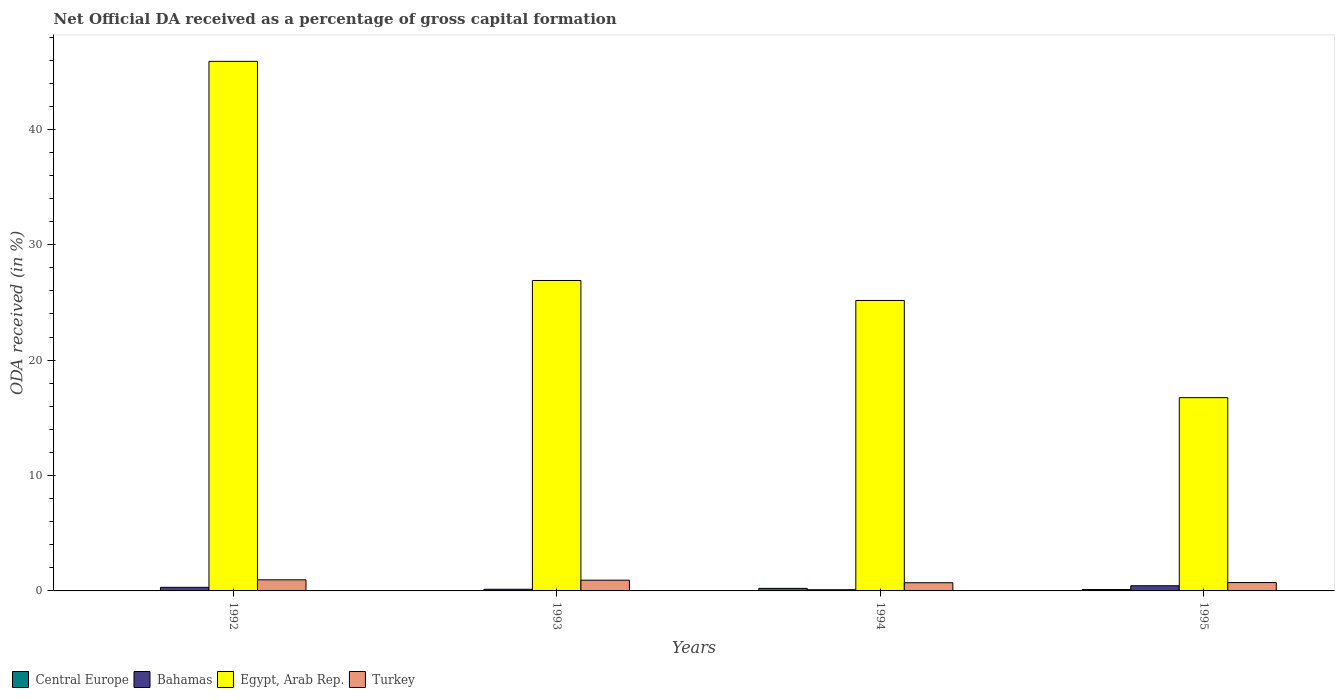How many different coloured bars are there?
Make the answer very short. 4. How many groups of bars are there?
Provide a short and direct response. 4. Are the number of bars per tick equal to the number of legend labels?
Your answer should be very brief. Yes. What is the label of the 4th group of bars from the left?
Make the answer very short. 1995. In how many cases, is the number of bars for a given year not equal to the number of legend labels?
Offer a very short reply. 0. What is the net ODA received in Egypt, Arab Rep. in 1994?
Your answer should be very brief. 25.17. Across all years, what is the maximum net ODA received in Central Europe?
Keep it short and to the point. 0.22. Across all years, what is the minimum net ODA received in Turkey?
Give a very brief answer. 0.71. In which year was the net ODA received in Turkey maximum?
Offer a very short reply. 1992. In which year was the net ODA received in Bahamas minimum?
Your response must be concise. 1994. What is the total net ODA received in Turkey in the graph?
Your answer should be very brief. 3.33. What is the difference between the net ODA received in Bahamas in 1994 and that in 1995?
Provide a short and direct response. -0.35. What is the difference between the net ODA received in Egypt, Arab Rep. in 1994 and the net ODA received in Bahamas in 1995?
Ensure brevity in your answer.  24.72. What is the average net ODA received in Egypt, Arab Rep. per year?
Your response must be concise. 28.68. In the year 1992, what is the difference between the net ODA received in Egypt, Arab Rep. and net ODA received in Central Europe?
Provide a short and direct response. 45.89. What is the ratio of the net ODA received in Turkey in 1994 to that in 1995?
Provide a short and direct response. 0.98. What is the difference between the highest and the second highest net ODA received in Turkey?
Provide a succinct answer. 0.03. What is the difference between the highest and the lowest net ODA received in Central Europe?
Keep it short and to the point. 0.22. Is it the case that in every year, the sum of the net ODA received in Central Europe and net ODA received in Turkey is greater than the sum of net ODA received in Bahamas and net ODA received in Egypt, Arab Rep.?
Provide a short and direct response. Yes. What does the 1st bar from the right in 1993 represents?
Ensure brevity in your answer.  Turkey. Is it the case that in every year, the sum of the net ODA received in Turkey and net ODA received in Egypt, Arab Rep. is greater than the net ODA received in Bahamas?
Your response must be concise. Yes. Are all the bars in the graph horizontal?
Make the answer very short. No. How many years are there in the graph?
Give a very brief answer. 4. What is the difference between two consecutive major ticks on the Y-axis?
Ensure brevity in your answer.  10. Are the values on the major ticks of Y-axis written in scientific E-notation?
Provide a short and direct response. No. Does the graph contain any zero values?
Your response must be concise. No. Does the graph contain grids?
Offer a very short reply. No. Where does the legend appear in the graph?
Offer a very short reply. Bottom left. What is the title of the graph?
Your answer should be very brief. Net Official DA received as a percentage of gross capital formation. Does "Korea (Republic)" appear as one of the legend labels in the graph?
Provide a short and direct response. No. What is the label or title of the X-axis?
Offer a terse response. Years. What is the label or title of the Y-axis?
Keep it short and to the point. ODA received (in %). What is the ODA received (in %) in Central Europe in 1992?
Make the answer very short. 2.00332790162036e-5. What is the ODA received (in %) in Bahamas in 1992?
Make the answer very short. 0.31. What is the ODA received (in %) of Egypt, Arab Rep. in 1992?
Your answer should be compact. 45.89. What is the ODA received (in %) in Turkey in 1992?
Your answer should be compact. 0.96. What is the ODA received (in %) of Central Europe in 1993?
Ensure brevity in your answer.  0.01. What is the ODA received (in %) of Bahamas in 1993?
Your answer should be very brief. 0.14. What is the ODA received (in %) in Egypt, Arab Rep. in 1993?
Give a very brief answer. 26.9. What is the ODA received (in %) in Turkey in 1993?
Offer a very short reply. 0.93. What is the ODA received (in %) of Central Europe in 1994?
Keep it short and to the point. 0.22. What is the ODA received (in %) of Bahamas in 1994?
Give a very brief answer. 0.1. What is the ODA received (in %) in Egypt, Arab Rep. in 1994?
Provide a succinct answer. 25.17. What is the ODA received (in %) in Turkey in 1994?
Offer a very short reply. 0.71. What is the ODA received (in %) in Central Europe in 1995?
Ensure brevity in your answer.  0.12. What is the ODA received (in %) in Bahamas in 1995?
Ensure brevity in your answer.  0.45. What is the ODA received (in %) of Egypt, Arab Rep. in 1995?
Give a very brief answer. 16.75. What is the ODA received (in %) of Turkey in 1995?
Provide a succinct answer. 0.72. Across all years, what is the maximum ODA received (in %) of Central Europe?
Offer a very short reply. 0.22. Across all years, what is the maximum ODA received (in %) of Bahamas?
Provide a short and direct response. 0.45. Across all years, what is the maximum ODA received (in %) of Egypt, Arab Rep.?
Your answer should be very brief. 45.89. Across all years, what is the maximum ODA received (in %) in Turkey?
Provide a succinct answer. 0.96. Across all years, what is the minimum ODA received (in %) in Central Europe?
Your answer should be compact. 2.00332790162036e-5. Across all years, what is the minimum ODA received (in %) in Bahamas?
Your answer should be very brief. 0.1. Across all years, what is the minimum ODA received (in %) in Egypt, Arab Rep.?
Keep it short and to the point. 16.75. Across all years, what is the minimum ODA received (in %) in Turkey?
Your answer should be compact. 0.71. What is the total ODA received (in %) of Central Europe in the graph?
Provide a short and direct response. 0.35. What is the total ODA received (in %) in Bahamas in the graph?
Ensure brevity in your answer.  1.01. What is the total ODA received (in %) of Egypt, Arab Rep. in the graph?
Your answer should be compact. 114.72. What is the total ODA received (in %) in Turkey in the graph?
Provide a short and direct response. 3.33. What is the difference between the ODA received (in %) of Central Europe in 1992 and that in 1993?
Provide a short and direct response. -0.01. What is the difference between the ODA received (in %) of Bahamas in 1992 and that in 1993?
Your answer should be compact. 0.17. What is the difference between the ODA received (in %) of Egypt, Arab Rep. in 1992 and that in 1993?
Ensure brevity in your answer.  18.99. What is the difference between the ODA received (in %) in Turkey in 1992 and that in 1993?
Give a very brief answer. 0.03. What is the difference between the ODA received (in %) in Central Europe in 1992 and that in 1994?
Give a very brief answer. -0.22. What is the difference between the ODA received (in %) in Bahamas in 1992 and that in 1994?
Provide a short and direct response. 0.21. What is the difference between the ODA received (in %) in Egypt, Arab Rep. in 1992 and that in 1994?
Your answer should be very brief. 20.72. What is the difference between the ODA received (in %) in Turkey in 1992 and that in 1994?
Offer a terse response. 0.25. What is the difference between the ODA received (in %) in Central Europe in 1992 and that in 1995?
Offer a terse response. -0.12. What is the difference between the ODA received (in %) of Bahamas in 1992 and that in 1995?
Offer a terse response. -0.14. What is the difference between the ODA received (in %) in Egypt, Arab Rep. in 1992 and that in 1995?
Your answer should be very brief. 29.15. What is the difference between the ODA received (in %) in Turkey in 1992 and that in 1995?
Give a very brief answer. 0.24. What is the difference between the ODA received (in %) of Central Europe in 1993 and that in 1994?
Offer a terse response. -0.21. What is the difference between the ODA received (in %) in Bahamas in 1993 and that in 1994?
Provide a short and direct response. 0.04. What is the difference between the ODA received (in %) in Egypt, Arab Rep. in 1993 and that in 1994?
Provide a succinct answer. 1.73. What is the difference between the ODA received (in %) in Turkey in 1993 and that in 1994?
Ensure brevity in your answer.  0.22. What is the difference between the ODA received (in %) in Central Europe in 1993 and that in 1995?
Offer a terse response. -0.11. What is the difference between the ODA received (in %) in Bahamas in 1993 and that in 1995?
Offer a very short reply. -0.31. What is the difference between the ODA received (in %) of Egypt, Arab Rep. in 1993 and that in 1995?
Provide a short and direct response. 10.16. What is the difference between the ODA received (in %) of Turkey in 1993 and that in 1995?
Offer a terse response. 0.21. What is the difference between the ODA received (in %) of Central Europe in 1994 and that in 1995?
Your response must be concise. 0.1. What is the difference between the ODA received (in %) in Bahamas in 1994 and that in 1995?
Provide a short and direct response. -0.35. What is the difference between the ODA received (in %) of Egypt, Arab Rep. in 1994 and that in 1995?
Provide a succinct answer. 8.42. What is the difference between the ODA received (in %) of Turkey in 1994 and that in 1995?
Your answer should be very brief. -0.02. What is the difference between the ODA received (in %) in Central Europe in 1992 and the ODA received (in %) in Bahamas in 1993?
Keep it short and to the point. -0.14. What is the difference between the ODA received (in %) of Central Europe in 1992 and the ODA received (in %) of Egypt, Arab Rep. in 1993?
Give a very brief answer. -26.9. What is the difference between the ODA received (in %) in Central Europe in 1992 and the ODA received (in %) in Turkey in 1993?
Provide a short and direct response. -0.93. What is the difference between the ODA received (in %) of Bahamas in 1992 and the ODA received (in %) of Egypt, Arab Rep. in 1993?
Your answer should be compact. -26.59. What is the difference between the ODA received (in %) in Bahamas in 1992 and the ODA received (in %) in Turkey in 1993?
Offer a very short reply. -0.62. What is the difference between the ODA received (in %) of Egypt, Arab Rep. in 1992 and the ODA received (in %) of Turkey in 1993?
Make the answer very short. 44.96. What is the difference between the ODA received (in %) in Central Europe in 1992 and the ODA received (in %) in Bahamas in 1994?
Keep it short and to the point. -0.1. What is the difference between the ODA received (in %) of Central Europe in 1992 and the ODA received (in %) of Egypt, Arab Rep. in 1994?
Provide a succinct answer. -25.17. What is the difference between the ODA received (in %) in Central Europe in 1992 and the ODA received (in %) in Turkey in 1994?
Your response must be concise. -0.71. What is the difference between the ODA received (in %) of Bahamas in 1992 and the ODA received (in %) of Egypt, Arab Rep. in 1994?
Offer a very short reply. -24.86. What is the difference between the ODA received (in %) of Bahamas in 1992 and the ODA received (in %) of Turkey in 1994?
Provide a succinct answer. -0.4. What is the difference between the ODA received (in %) in Egypt, Arab Rep. in 1992 and the ODA received (in %) in Turkey in 1994?
Provide a short and direct response. 45.19. What is the difference between the ODA received (in %) in Central Europe in 1992 and the ODA received (in %) in Bahamas in 1995?
Keep it short and to the point. -0.45. What is the difference between the ODA received (in %) in Central Europe in 1992 and the ODA received (in %) in Egypt, Arab Rep. in 1995?
Ensure brevity in your answer.  -16.75. What is the difference between the ODA received (in %) of Central Europe in 1992 and the ODA received (in %) of Turkey in 1995?
Provide a succinct answer. -0.72. What is the difference between the ODA received (in %) in Bahamas in 1992 and the ODA received (in %) in Egypt, Arab Rep. in 1995?
Keep it short and to the point. -16.44. What is the difference between the ODA received (in %) in Bahamas in 1992 and the ODA received (in %) in Turkey in 1995?
Your response must be concise. -0.41. What is the difference between the ODA received (in %) of Egypt, Arab Rep. in 1992 and the ODA received (in %) of Turkey in 1995?
Offer a very short reply. 45.17. What is the difference between the ODA received (in %) of Central Europe in 1993 and the ODA received (in %) of Bahamas in 1994?
Keep it short and to the point. -0.09. What is the difference between the ODA received (in %) of Central Europe in 1993 and the ODA received (in %) of Egypt, Arab Rep. in 1994?
Your answer should be very brief. -25.16. What is the difference between the ODA received (in %) of Central Europe in 1993 and the ODA received (in %) of Turkey in 1994?
Provide a succinct answer. -0.69. What is the difference between the ODA received (in %) of Bahamas in 1993 and the ODA received (in %) of Egypt, Arab Rep. in 1994?
Ensure brevity in your answer.  -25.03. What is the difference between the ODA received (in %) of Bahamas in 1993 and the ODA received (in %) of Turkey in 1994?
Provide a short and direct response. -0.57. What is the difference between the ODA received (in %) in Egypt, Arab Rep. in 1993 and the ODA received (in %) in Turkey in 1994?
Provide a succinct answer. 26.2. What is the difference between the ODA received (in %) in Central Europe in 1993 and the ODA received (in %) in Bahamas in 1995?
Give a very brief answer. -0.44. What is the difference between the ODA received (in %) in Central Europe in 1993 and the ODA received (in %) in Egypt, Arab Rep. in 1995?
Ensure brevity in your answer.  -16.73. What is the difference between the ODA received (in %) in Central Europe in 1993 and the ODA received (in %) in Turkey in 1995?
Keep it short and to the point. -0.71. What is the difference between the ODA received (in %) of Bahamas in 1993 and the ODA received (in %) of Egypt, Arab Rep. in 1995?
Offer a very short reply. -16.61. What is the difference between the ODA received (in %) in Bahamas in 1993 and the ODA received (in %) in Turkey in 1995?
Your answer should be compact. -0.58. What is the difference between the ODA received (in %) of Egypt, Arab Rep. in 1993 and the ODA received (in %) of Turkey in 1995?
Your answer should be compact. 26.18. What is the difference between the ODA received (in %) in Central Europe in 1994 and the ODA received (in %) in Bahamas in 1995?
Offer a very short reply. -0.23. What is the difference between the ODA received (in %) in Central Europe in 1994 and the ODA received (in %) in Egypt, Arab Rep. in 1995?
Your response must be concise. -16.53. What is the difference between the ODA received (in %) in Central Europe in 1994 and the ODA received (in %) in Turkey in 1995?
Keep it short and to the point. -0.5. What is the difference between the ODA received (in %) of Bahamas in 1994 and the ODA received (in %) of Egypt, Arab Rep. in 1995?
Make the answer very short. -16.64. What is the difference between the ODA received (in %) in Bahamas in 1994 and the ODA received (in %) in Turkey in 1995?
Give a very brief answer. -0.62. What is the difference between the ODA received (in %) of Egypt, Arab Rep. in 1994 and the ODA received (in %) of Turkey in 1995?
Offer a very short reply. 24.45. What is the average ODA received (in %) in Central Europe per year?
Keep it short and to the point. 0.09. What is the average ODA received (in %) in Bahamas per year?
Your answer should be compact. 0.25. What is the average ODA received (in %) in Egypt, Arab Rep. per year?
Your answer should be compact. 28.68. What is the average ODA received (in %) in Turkey per year?
Keep it short and to the point. 0.83. In the year 1992, what is the difference between the ODA received (in %) of Central Europe and ODA received (in %) of Bahamas?
Provide a succinct answer. -0.31. In the year 1992, what is the difference between the ODA received (in %) in Central Europe and ODA received (in %) in Egypt, Arab Rep.?
Offer a very short reply. -45.89. In the year 1992, what is the difference between the ODA received (in %) in Central Europe and ODA received (in %) in Turkey?
Your response must be concise. -0.96. In the year 1992, what is the difference between the ODA received (in %) of Bahamas and ODA received (in %) of Egypt, Arab Rep.?
Your response must be concise. -45.58. In the year 1992, what is the difference between the ODA received (in %) of Bahamas and ODA received (in %) of Turkey?
Provide a short and direct response. -0.65. In the year 1992, what is the difference between the ODA received (in %) of Egypt, Arab Rep. and ODA received (in %) of Turkey?
Your answer should be very brief. 44.93. In the year 1993, what is the difference between the ODA received (in %) in Central Europe and ODA received (in %) in Bahamas?
Ensure brevity in your answer.  -0.13. In the year 1993, what is the difference between the ODA received (in %) in Central Europe and ODA received (in %) in Egypt, Arab Rep.?
Give a very brief answer. -26.89. In the year 1993, what is the difference between the ODA received (in %) in Central Europe and ODA received (in %) in Turkey?
Your response must be concise. -0.92. In the year 1993, what is the difference between the ODA received (in %) of Bahamas and ODA received (in %) of Egypt, Arab Rep.?
Your response must be concise. -26.76. In the year 1993, what is the difference between the ODA received (in %) of Bahamas and ODA received (in %) of Turkey?
Provide a short and direct response. -0.79. In the year 1993, what is the difference between the ODA received (in %) of Egypt, Arab Rep. and ODA received (in %) of Turkey?
Provide a short and direct response. 25.97. In the year 1994, what is the difference between the ODA received (in %) in Central Europe and ODA received (in %) in Bahamas?
Give a very brief answer. 0.12. In the year 1994, what is the difference between the ODA received (in %) in Central Europe and ODA received (in %) in Egypt, Arab Rep.?
Provide a short and direct response. -24.95. In the year 1994, what is the difference between the ODA received (in %) of Central Europe and ODA received (in %) of Turkey?
Your answer should be compact. -0.49. In the year 1994, what is the difference between the ODA received (in %) of Bahamas and ODA received (in %) of Egypt, Arab Rep.?
Make the answer very short. -25.07. In the year 1994, what is the difference between the ODA received (in %) of Bahamas and ODA received (in %) of Turkey?
Make the answer very short. -0.6. In the year 1994, what is the difference between the ODA received (in %) of Egypt, Arab Rep. and ODA received (in %) of Turkey?
Provide a short and direct response. 24.46. In the year 1995, what is the difference between the ODA received (in %) in Central Europe and ODA received (in %) in Bahamas?
Make the answer very short. -0.33. In the year 1995, what is the difference between the ODA received (in %) in Central Europe and ODA received (in %) in Egypt, Arab Rep.?
Provide a succinct answer. -16.63. In the year 1995, what is the difference between the ODA received (in %) of Central Europe and ODA received (in %) of Turkey?
Offer a terse response. -0.6. In the year 1995, what is the difference between the ODA received (in %) in Bahamas and ODA received (in %) in Egypt, Arab Rep.?
Provide a succinct answer. -16.3. In the year 1995, what is the difference between the ODA received (in %) of Bahamas and ODA received (in %) of Turkey?
Keep it short and to the point. -0.27. In the year 1995, what is the difference between the ODA received (in %) in Egypt, Arab Rep. and ODA received (in %) in Turkey?
Make the answer very short. 16.02. What is the ratio of the ODA received (in %) of Central Europe in 1992 to that in 1993?
Your response must be concise. 0. What is the ratio of the ODA received (in %) in Bahamas in 1992 to that in 1993?
Provide a succinct answer. 2.18. What is the ratio of the ODA received (in %) of Egypt, Arab Rep. in 1992 to that in 1993?
Your answer should be compact. 1.71. What is the ratio of the ODA received (in %) in Turkey in 1992 to that in 1993?
Ensure brevity in your answer.  1.03. What is the ratio of the ODA received (in %) in Bahamas in 1992 to that in 1994?
Give a very brief answer. 3.02. What is the ratio of the ODA received (in %) of Egypt, Arab Rep. in 1992 to that in 1994?
Offer a terse response. 1.82. What is the ratio of the ODA received (in %) of Turkey in 1992 to that in 1994?
Give a very brief answer. 1.36. What is the ratio of the ODA received (in %) of Bahamas in 1992 to that in 1995?
Ensure brevity in your answer.  0.69. What is the ratio of the ODA received (in %) of Egypt, Arab Rep. in 1992 to that in 1995?
Provide a short and direct response. 2.74. What is the ratio of the ODA received (in %) of Turkey in 1992 to that in 1995?
Your answer should be compact. 1.33. What is the ratio of the ODA received (in %) of Central Europe in 1993 to that in 1994?
Your answer should be very brief. 0.06. What is the ratio of the ODA received (in %) in Bahamas in 1993 to that in 1994?
Ensure brevity in your answer.  1.38. What is the ratio of the ODA received (in %) of Egypt, Arab Rep. in 1993 to that in 1994?
Make the answer very short. 1.07. What is the ratio of the ODA received (in %) in Turkey in 1993 to that in 1994?
Your response must be concise. 1.32. What is the ratio of the ODA received (in %) of Central Europe in 1993 to that in 1995?
Your answer should be very brief. 0.11. What is the ratio of the ODA received (in %) in Bahamas in 1993 to that in 1995?
Give a very brief answer. 0.32. What is the ratio of the ODA received (in %) of Egypt, Arab Rep. in 1993 to that in 1995?
Make the answer very short. 1.61. What is the ratio of the ODA received (in %) of Turkey in 1993 to that in 1995?
Make the answer very short. 1.29. What is the ratio of the ODA received (in %) of Central Europe in 1994 to that in 1995?
Your response must be concise. 1.82. What is the ratio of the ODA received (in %) of Bahamas in 1994 to that in 1995?
Give a very brief answer. 0.23. What is the ratio of the ODA received (in %) of Egypt, Arab Rep. in 1994 to that in 1995?
Your response must be concise. 1.5. What is the ratio of the ODA received (in %) of Turkey in 1994 to that in 1995?
Make the answer very short. 0.98. What is the difference between the highest and the second highest ODA received (in %) of Central Europe?
Keep it short and to the point. 0.1. What is the difference between the highest and the second highest ODA received (in %) of Bahamas?
Your answer should be very brief. 0.14. What is the difference between the highest and the second highest ODA received (in %) in Egypt, Arab Rep.?
Your answer should be compact. 18.99. What is the difference between the highest and the second highest ODA received (in %) in Turkey?
Keep it short and to the point. 0.03. What is the difference between the highest and the lowest ODA received (in %) of Central Europe?
Your answer should be compact. 0.22. What is the difference between the highest and the lowest ODA received (in %) in Bahamas?
Offer a very short reply. 0.35. What is the difference between the highest and the lowest ODA received (in %) of Egypt, Arab Rep.?
Offer a terse response. 29.15. What is the difference between the highest and the lowest ODA received (in %) of Turkey?
Your answer should be compact. 0.25. 